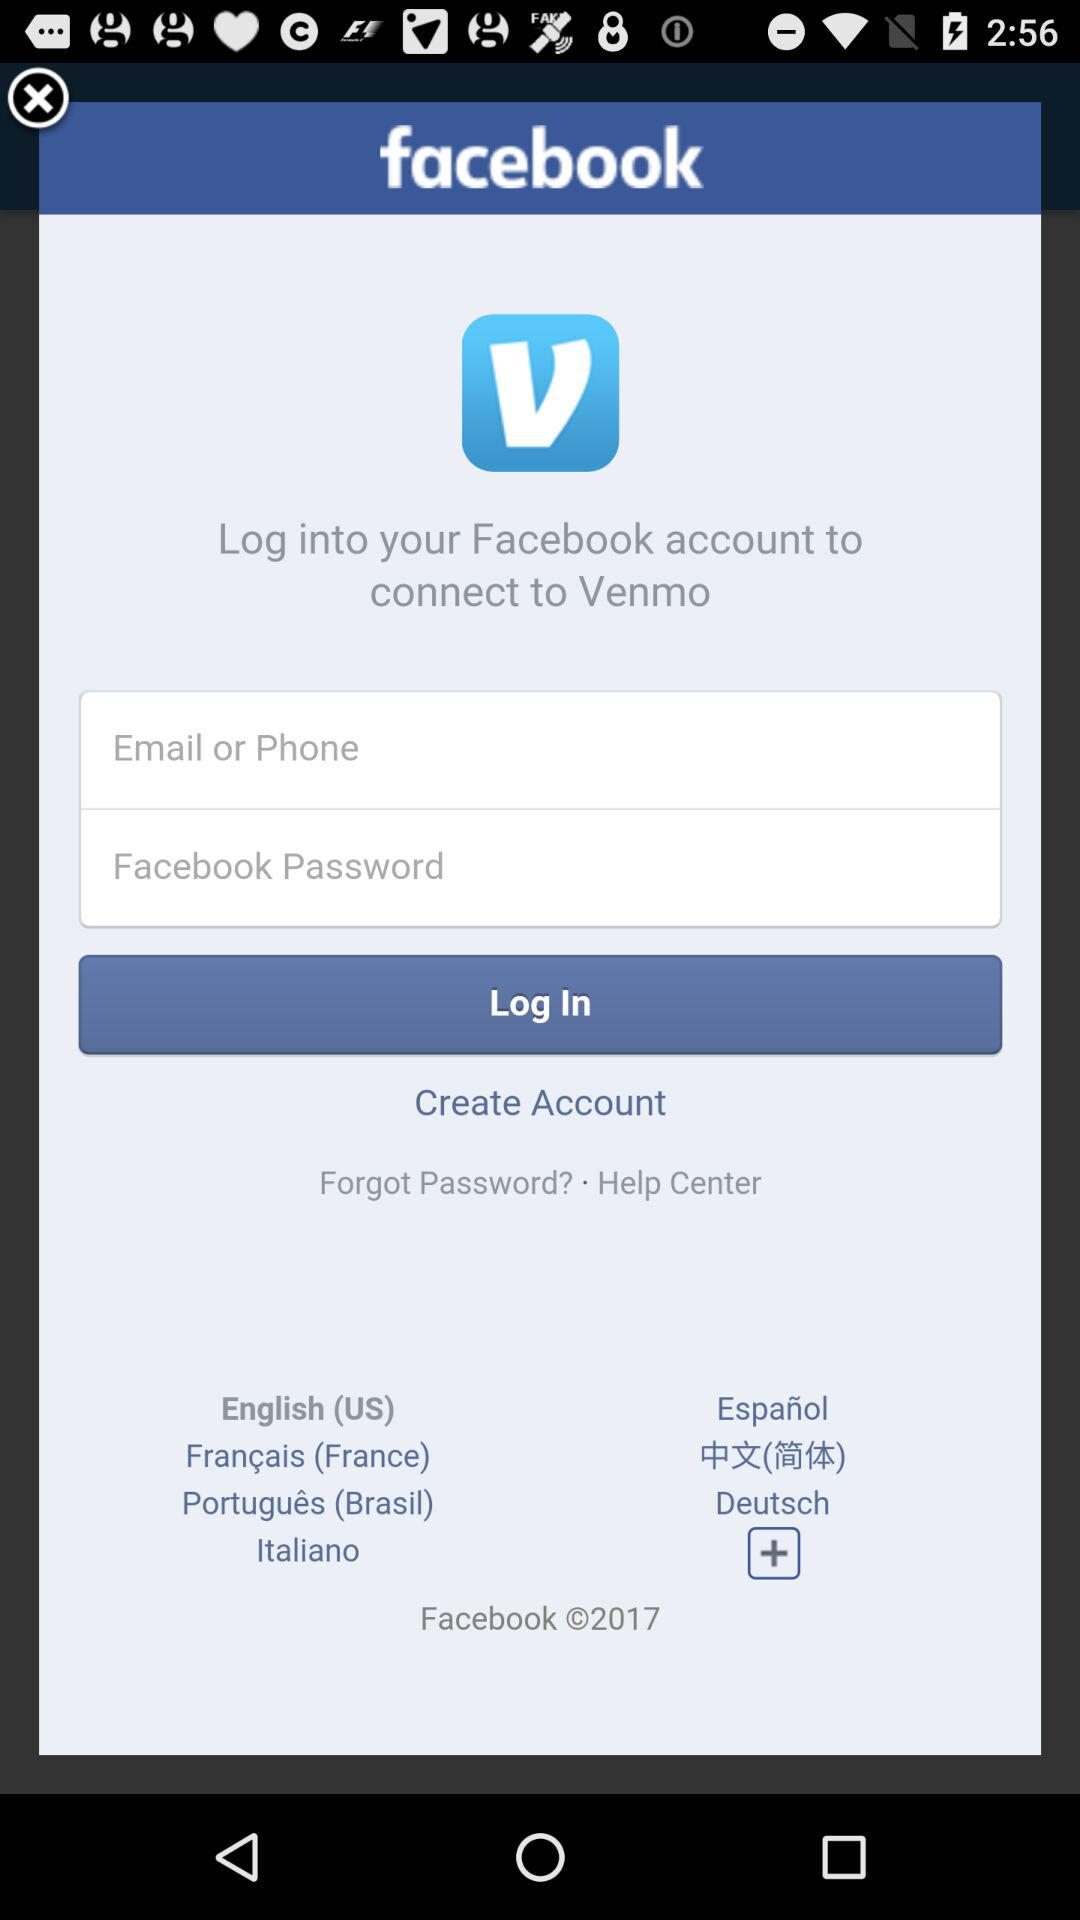What is the user's email address?
When the provided information is insufficient, respond with <no answer>. <no answer> 